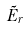<formula> <loc_0><loc_0><loc_500><loc_500>\tilde { E } _ { r }</formula> 